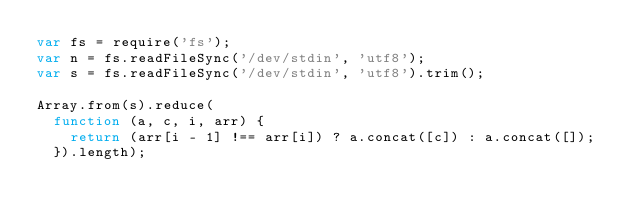<code> <loc_0><loc_0><loc_500><loc_500><_JavaScript_>var fs = require('fs');
var n = fs.readFileSync('/dev/stdin', 'utf8');
var s = fs.readFileSync('/dev/stdin', 'utf8').trim();
 
Array.from(s).reduce(
  function (a, c, i, arr) {
    return (arr[i - 1] !== arr[i]) ? a.concat([c]) : a.concat([]);
  }).length);</code> 